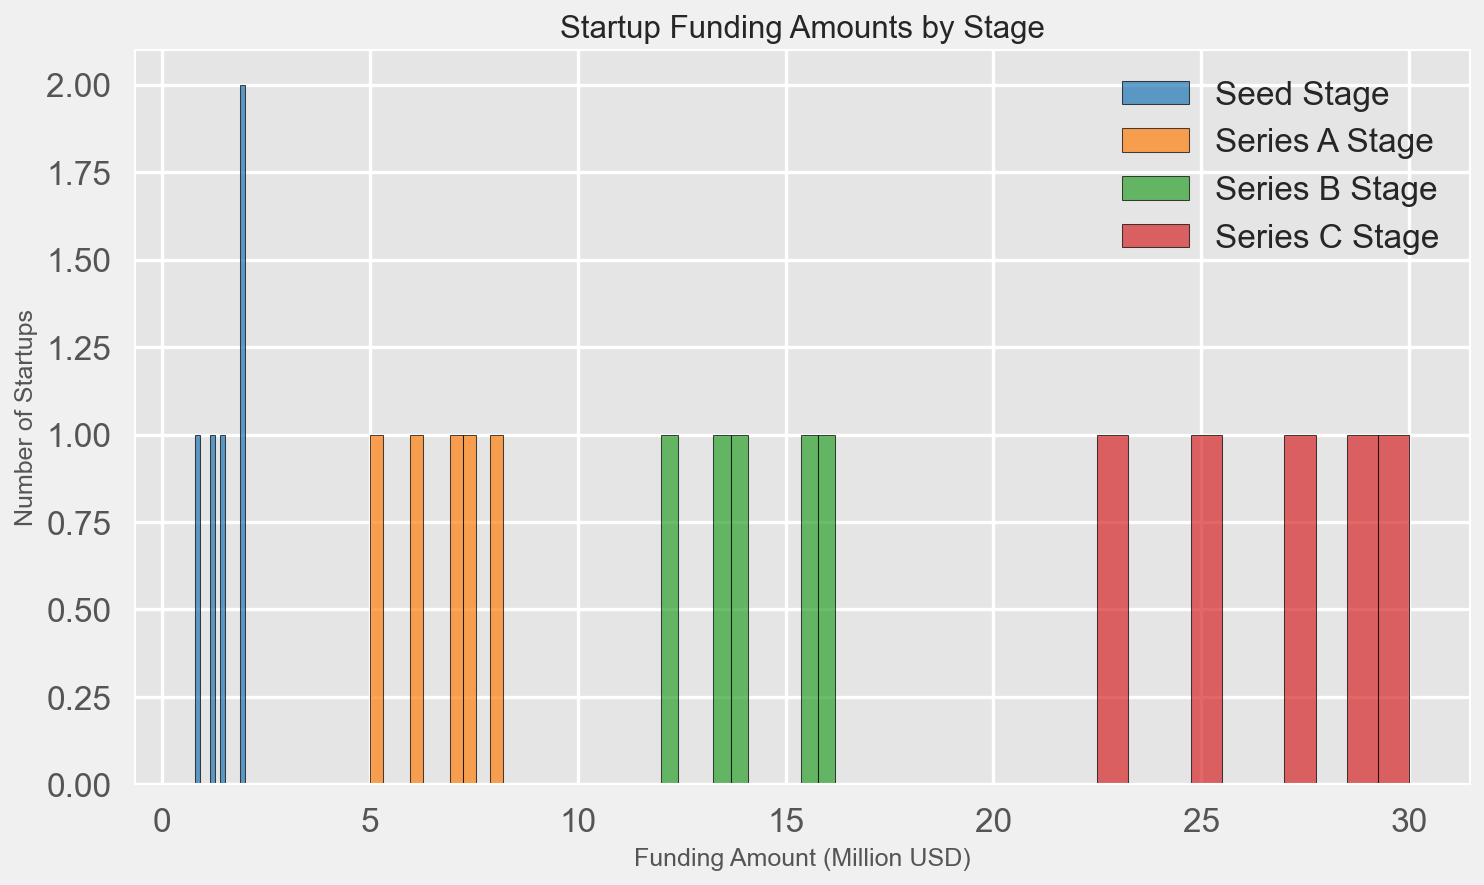What is the range of funding amounts in the Seed stage? Observe the lowest and highest data points in the Seed stage. The lowest funding amount is 0.8 million USD and the highest is 2.0 million USD. So, the range is 2.0 - 0.8 = 1.2 million USD.
Answer: 1.2 million USD Which stage has the highest median funding amount? To determine the median funding amount for each stage, arrange the data points in ascending order and find the middle value. The median for Seed is 1.5, for Series A is 7.0, for Series B is 14.0, and for Series C is 27.5. The highest among these figures is 27.5, found in Series C.
Answer: Series C How many startups are there with funding amounts between 6 and 8 million USD in the Series A stage? Count the number of data points in the Series A stage that fall between 6 and 8 million USD. The data points 6.0, 7.0, and 7.5 fall within this range, so there are 3 startups.
Answer: 3 Compare the highest funding amounts between Series B and Series D. Which stage has a higher amount? Observe the highest funding amounts in Series B and Series D. For Series B, it is 16.2 million USD, and for Series D, it is 52.0 million USD. Series D has a higher amount than Series B.
Answer: Series D What is the average funding amount for Series C? Sum the funding amounts for Series C and divide by the number of data points. (25.0 + 30.0 + 27.5 + 22.5 + 29.0) / 5 = 134.0 / 5 = 26.8 million USD.
Answer: 26.8 million USD Which stage has the greatest variation in funding amounts? Compare the ranges of funding amounts for each stage. Seed: 2.0 - 0.8 = 1.2, Series A: 8.2 - 5.0 = 3.2, Series B: 16.2 - 12.0 = 4.2, Series C: 30.0 - 22.5 = 7.5, Series D: 52.0 - 45.0 = 7.0. Series C has the greatest variation with a range of 7.5 million USD.
Answer: Series C How many more startups received funding in the Seed stage compared to the Series C stage? Count the total number of startups in the Seed and Series C stages. Seed has 5 startups, while Series C has 5 startups as well. Thus, the difference is 5 - 5 = 0.
Answer: 0 